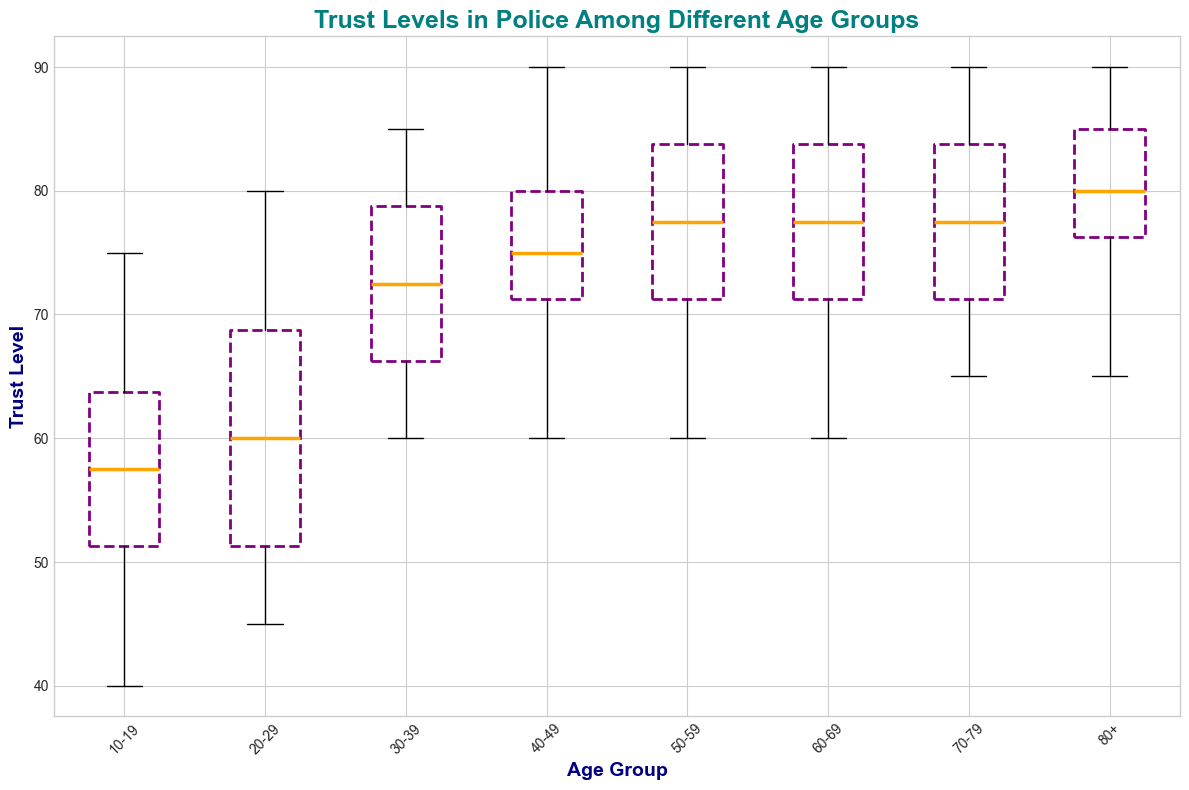What's the median trust level for the age group 10-19? Look at the middle line of the box for the age group 10-19. The median value is the value of this line.
Answer: 57.5 Which age group has the highest median trust level? Compare the median lines (the horizontal line inside each box) of all age groups. Identify the group with the highest median line.
Answer: 80+ What is the interquartile range (IQR) for the age group 30-39? The IQR is the difference between the third quartile (top edge of the box) and the first quartile (bottom edge of the box) for the age group 30-39.
Answer: 20 Which age group has the largest spread of trust levels? The spread is indicated by the range between the lowest and highest whiskers (lines extending from the boxes) on the plot. Identify the group with the largest range.
Answer: 10-19 How many age groups have a median trust level of 75 or higher? Count the age groups where the median line (horizontal line inside each box) is at 75 or above.
Answer: 5 Is the median trust level higher for age group 40-49 or 20-29? Compare the median lines (horizontal line inside each box) for age groups 40-49 and 20-29.
Answer: 40-49 Among all age groups, which one has the most consistent (least variation) trust levels? Consistency is indicated by the smallest box and whisker range. Identify the group with the smallest overall range.
Answer: 80+ What is the approximate range of trust levels for the age group 60-69? The range is the difference between the maximum and minimum values in the whiskers for the age group 60-69.
Answer: 30 Which age group has outliers, and how are they visually represented? Outliers are marked with red circles. Identify the age group that has these red circles.
Answer: 10-19 Compare the median trust levels between age groups 50-59 and 70-79. Which one is higher, and by how much? Look at the median lines for both age groups and compare their positions. Calculate the difference.
Answer: 70-79; 5 